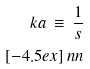Convert formula to latex. <formula><loc_0><loc_0><loc_500><loc_500>\ k a \, \equiv \, \frac { 1 } { s } \\ [ - 4 . 5 e x ] \ n n</formula> 